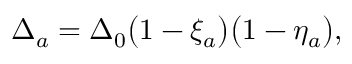Convert formula to latex. <formula><loc_0><loc_0><loc_500><loc_500>\Delta _ { a } = \Delta _ { 0 } \left ( 1 - \xi _ { a } \right ) \left ( 1 - \eta _ { a } \right ) ,</formula> 